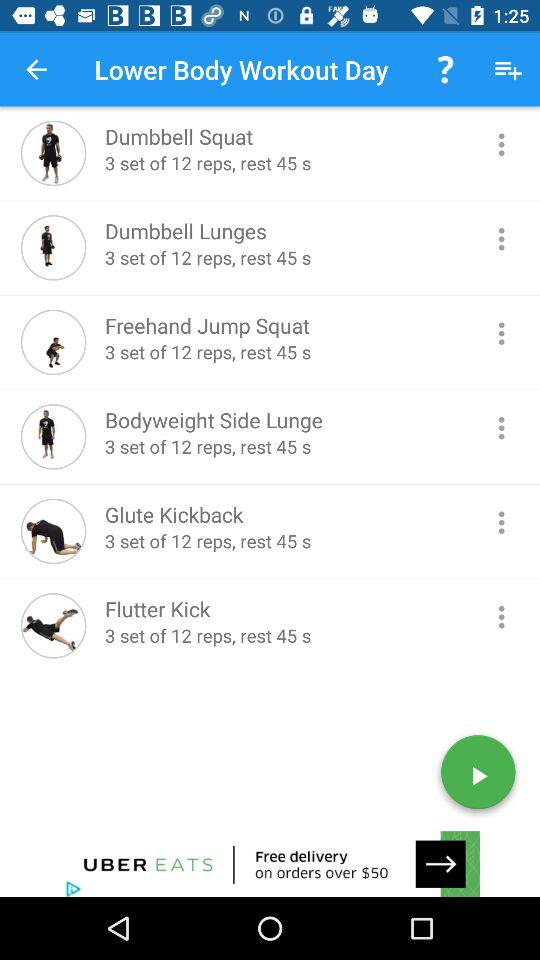How many sets and reps of "Dumbbell Squat" are to be done? There are 3 sets of 12 reps of "Dumbbell Squat" to be done. 